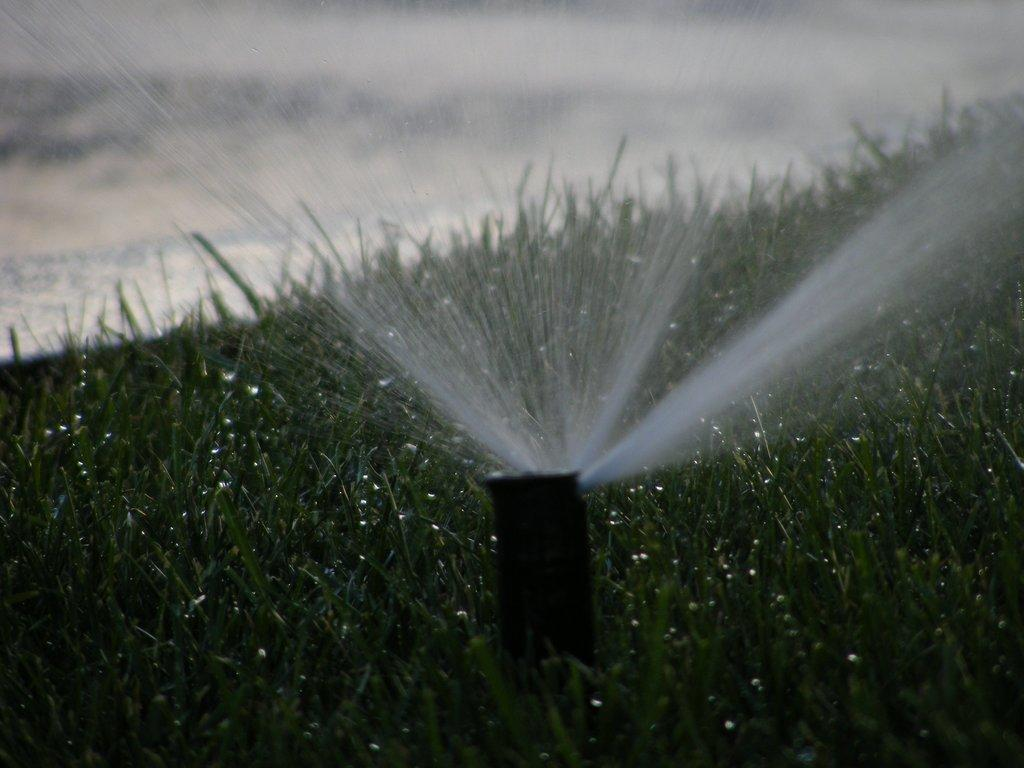What object is on the ground in the image? There is a water sprinkler on the ground. What type of vegetation is present on the ground? There is grass on the ground. Can you describe the background of the image? The background of the image is blurry. What type of comb is being used to remove zinc from the grass in the image? There is no comb or zinc present in the image; it features a water sprinkler on the ground with grass surrounding it. 